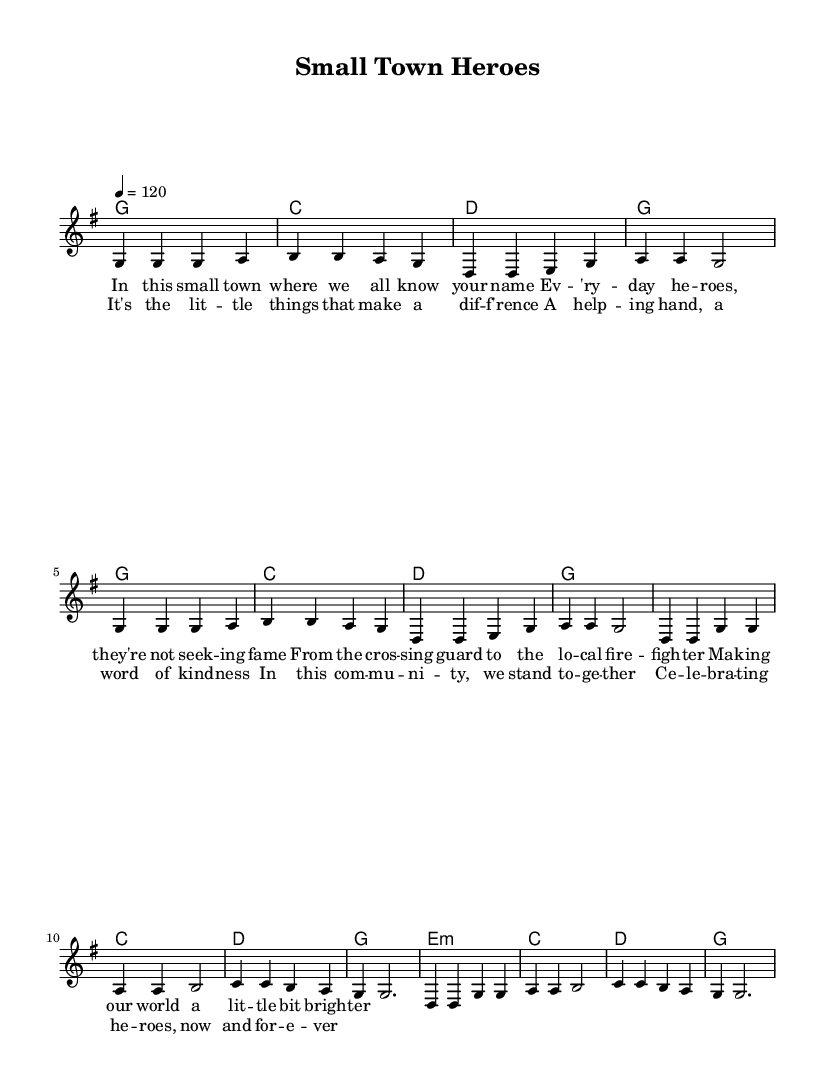What is the key signature of this music? The key signature is G major, which has one sharp (F#). This is indicated at the beginning of the sheet music where the key signature is shown.
Answer: G major What is the time signature used in this piece? The time signature is 4/4, as shown at the beginning of the staff notation. This indicates that there are four beats per measure and a quarter note receives one beat.
Answer: 4/4 What is the tempo marking for this song? The tempo marking is 120 beats per minute, indicated by "4 = 120" at the beginning of the score. This tells performers the speed at which to play the piece.
Answer: 120 How many measures are in the verse? The verse consists of 8 measures, which is determined by counting the vertical lines separating the segments in the melody section labeled as "Verse." Each measure holds 4 beats, aligning with the 4/4 time signature.
Answer: 8 What is the central theme of the lyrics? The central theme of the lyrics is community heroes, as stated in the verses celebrating everyday acts of kindness and the heroes within a small town context. This can be deduced by analyzing the content of the lyrics presented under "verseOne" and "chorus."
Answer: Community heroes What type of chords are primarily used in the chorus? The primary chords used in the chorus are major chords, as per the synchronization of phrases in the "harmonies" section where "g," "c," and "d" chords are prevalent. This resonates with the upbeat and celebratory nature of country music.
Answer: Major chords 